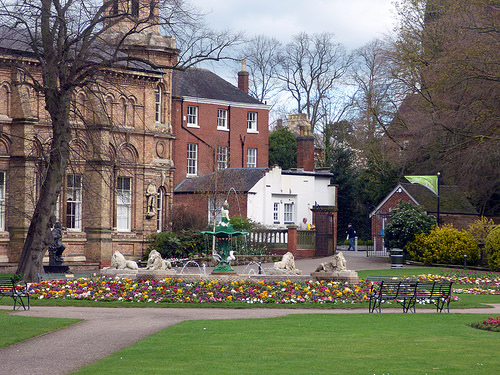<image>
Can you confirm if the lion statue is on the flowers? No. The lion statue is not positioned on the flowers. They may be near each other, but the lion statue is not supported by or resting on top of the flowers. Is the building in front of the grass? Yes. The building is positioned in front of the grass, appearing closer to the camera viewpoint. 